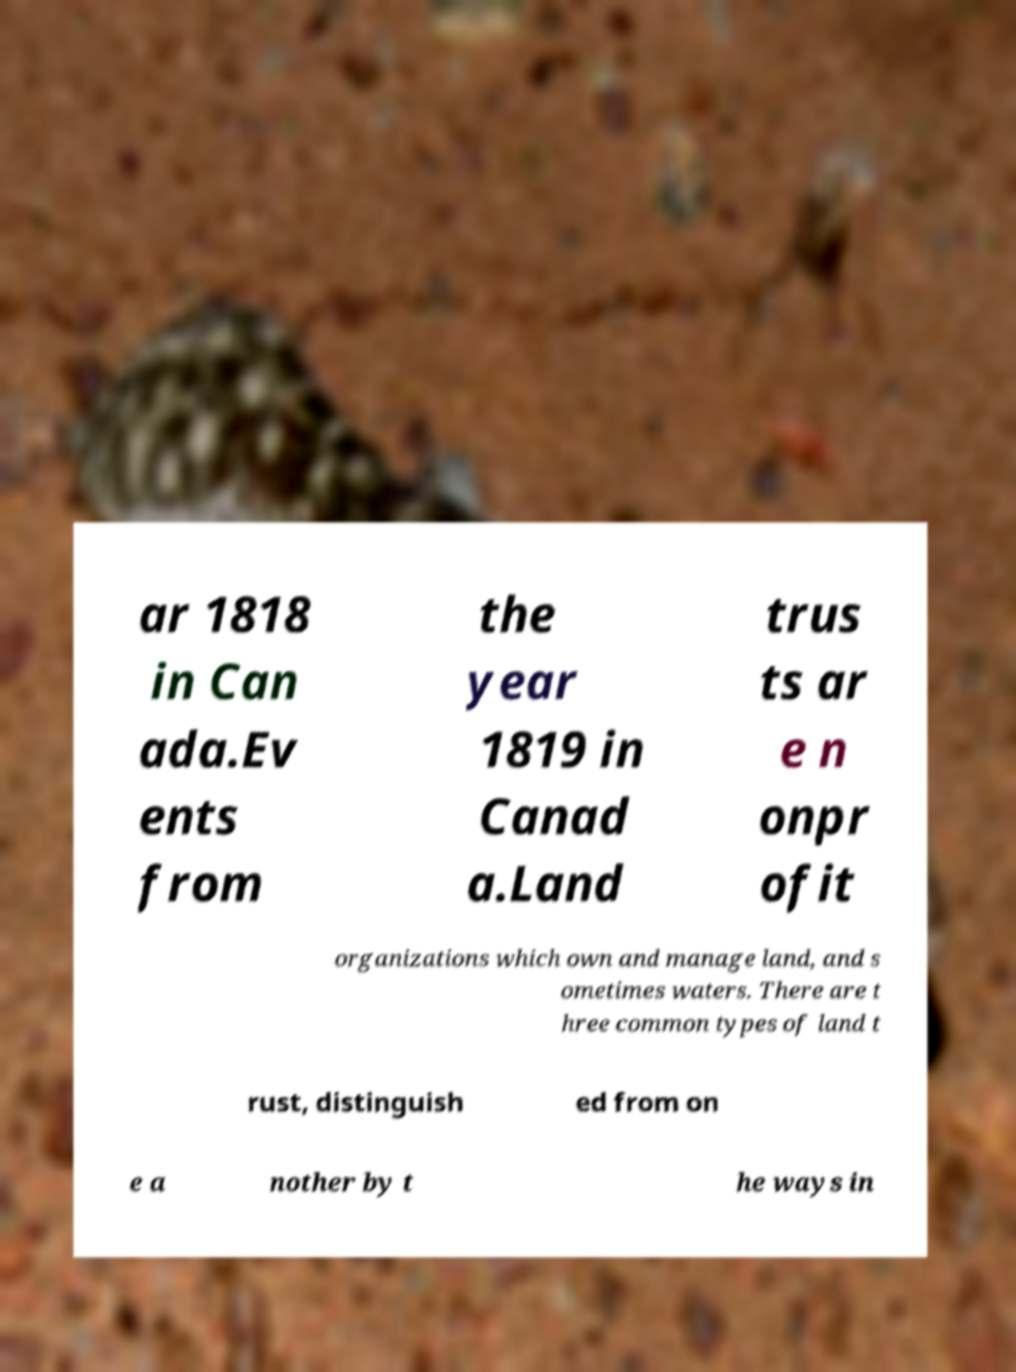Please identify and transcribe the text found in this image. ar 1818 in Can ada.Ev ents from the year 1819 in Canad a.Land trus ts ar e n onpr ofit organizations which own and manage land, and s ometimes waters. There are t hree common types of land t rust, distinguish ed from on e a nother by t he ways in 